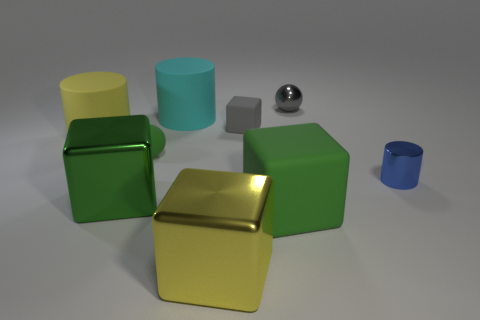There is a green matte thing that is right of the cyan cylinder; is its size the same as the small gray block?
Your answer should be very brief. No. There is a metal thing that is on the right side of the green shiny thing and in front of the tiny blue metallic object; how big is it?
Offer a very short reply. Large. What number of other objects are the same material as the tiny gray block?
Your answer should be very brief. 4. There is a rubber block that is behind the green rubber ball; what size is it?
Your answer should be compact. Small. Is the small metal ball the same color as the small block?
Your response must be concise. Yes. What number of large things are either yellow rubber cylinders or green rubber things?
Give a very brief answer. 2. Is there anything else that has the same color as the small metal cylinder?
Ensure brevity in your answer.  No. There is a small gray block; are there any blue cylinders behind it?
Your response must be concise. No. What is the size of the green object behind the cylinder that is on the right side of the small gray metal sphere?
Your answer should be very brief. Small. Is the number of green matte objects left of the large green rubber cube the same as the number of tiny green matte things on the right side of the big green shiny object?
Give a very brief answer. Yes. 